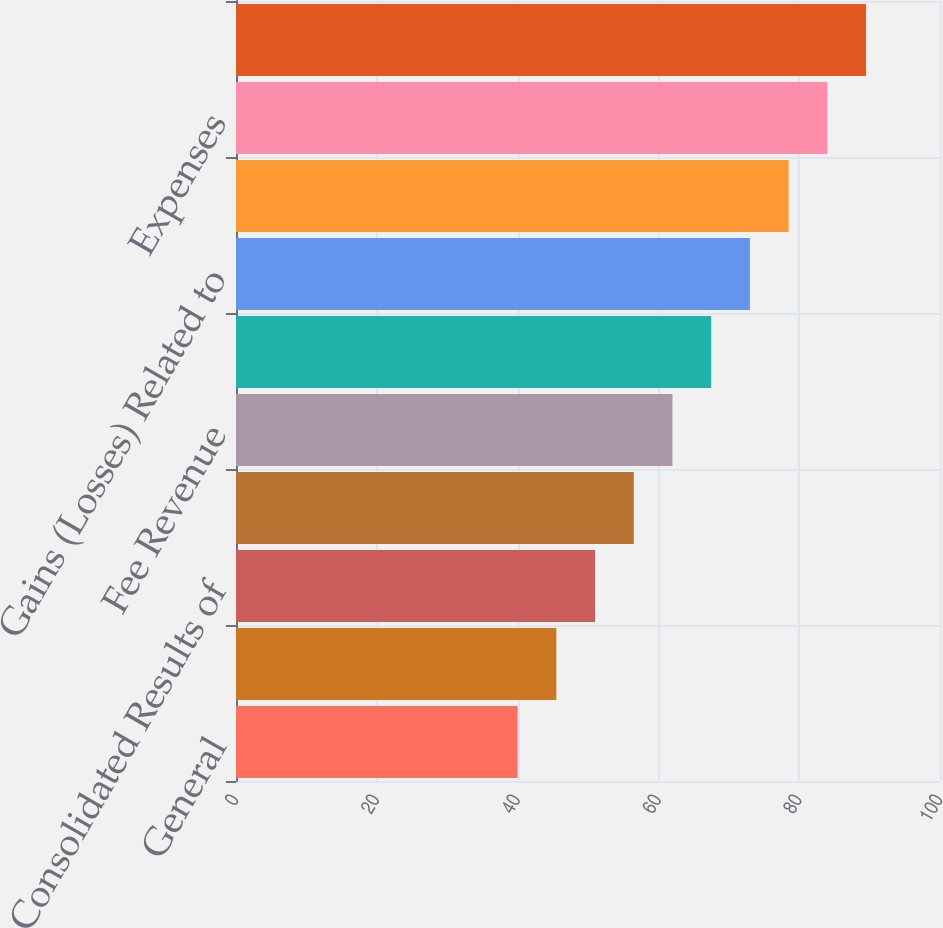Convert chart. <chart><loc_0><loc_0><loc_500><loc_500><bar_chart><fcel>General<fcel>Overview of Financial Results<fcel>Consolidated Results of<fcel>Total Revenue<fcel>Fee Revenue<fcel>Net Interest Revenue<fcel>Gains (Losses) Related to<fcel>Provision for Loan Losses<fcel>Expenses<fcel>Income Taxes<nl><fcel>40<fcel>45.5<fcel>51<fcel>56.5<fcel>62<fcel>67.5<fcel>73<fcel>78.5<fcel>84<fcel>89.5<nl></chart> 